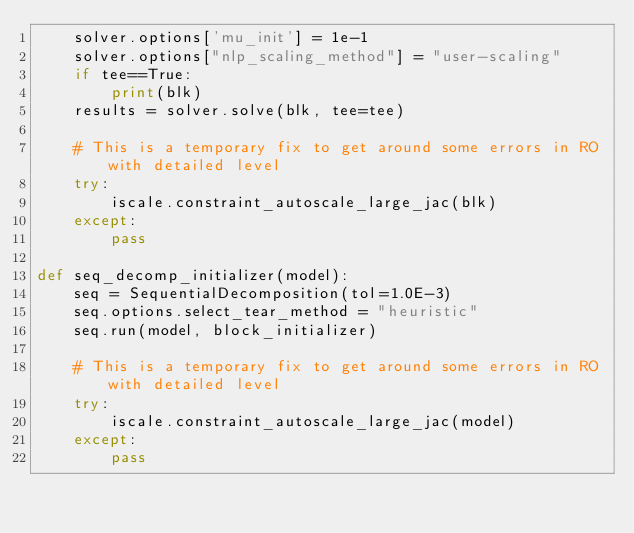Convert code to text. <code><loc_0><loc_0><loc_500><loc_500><_Python_>    solver.options['mu_init'] = 1e-1
    solver.options["nlp_scaling_method"] = "user-scaling"
    if tee==True:
        print(blk)
    results = solver.solve(blk, tee=tee)

    # This is a temporary fix to get around some errors in RO with detailed level
    try:
        iscale.constraint_autoscale_large_jac(blk)
    except:
        pass

def seq_decomp_initializer(model):
    seq = SequentialDecomposition(tol=1.0E-3)
    seq.options.select_tear_method = "heuristic"
    seq.run(model, block_initializer)

    # This is a temporary fix to get around some errors in RO with detailed level
    try:
        iscale.constraint_autoscale_large_jac(model)
    except:
        pass
</code> 